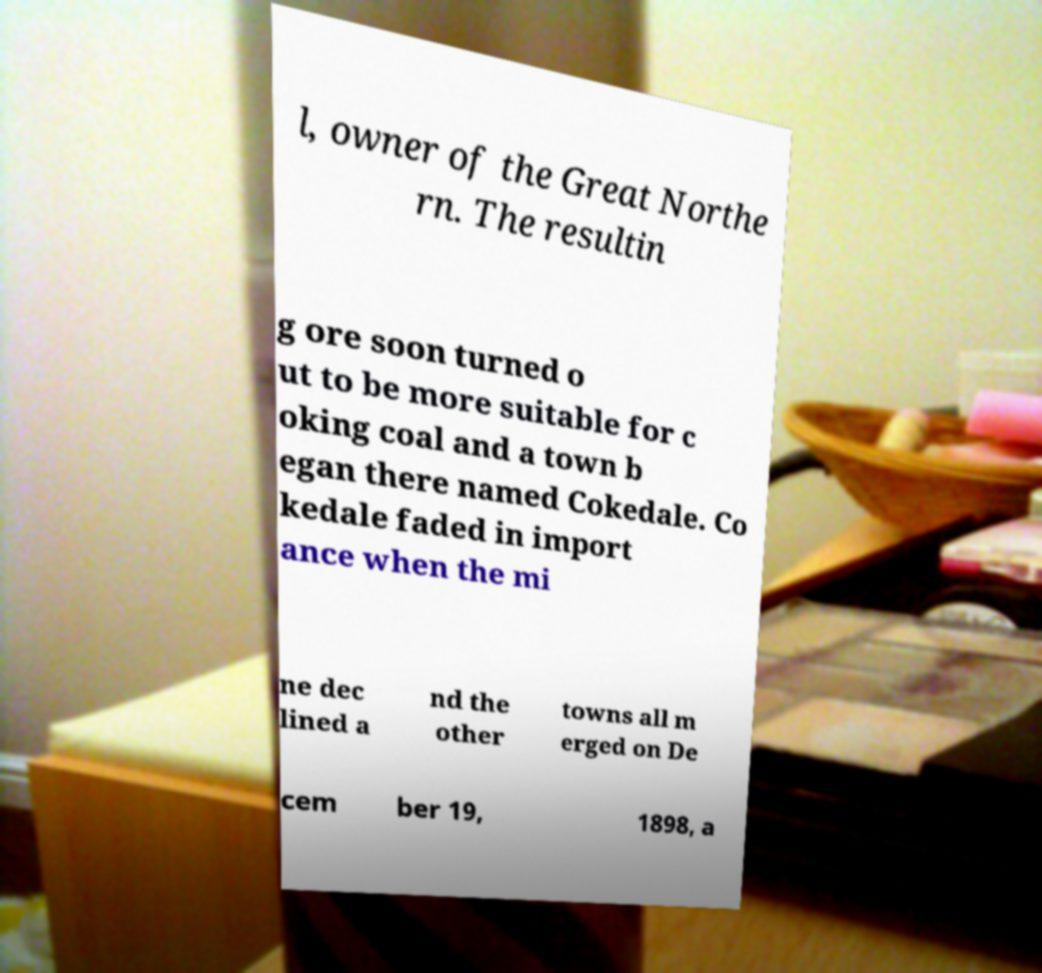Please read and relay the text visible in this image. What does it say? l, owner of the Great Northe rn. The resultin g ore soon turned o ut to be more suitable for c oking coal and a town b egan there named Cokedale. Co kedale faded in import ance when the mi ne dec lined a nd the other towns all m erged on De cem ber 19, 1898, a 